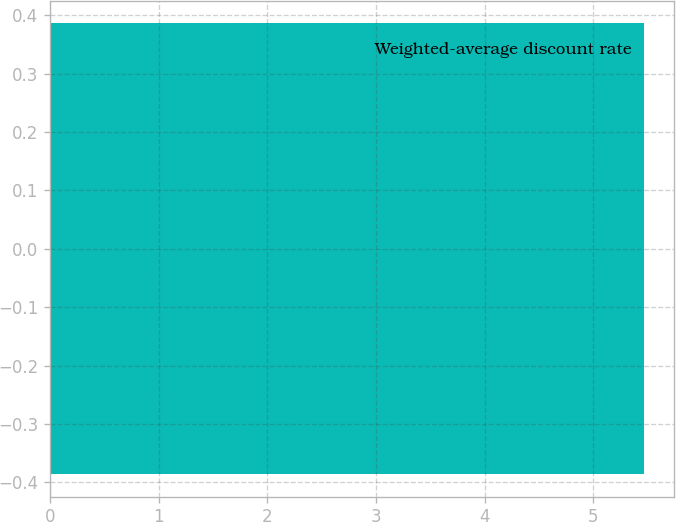<chart> <loc_0><loc_0><loc_500><loc_500><bar_chart><fcel>Weighted-average discount rate<nl><fcel>5.47<nl></chart> 